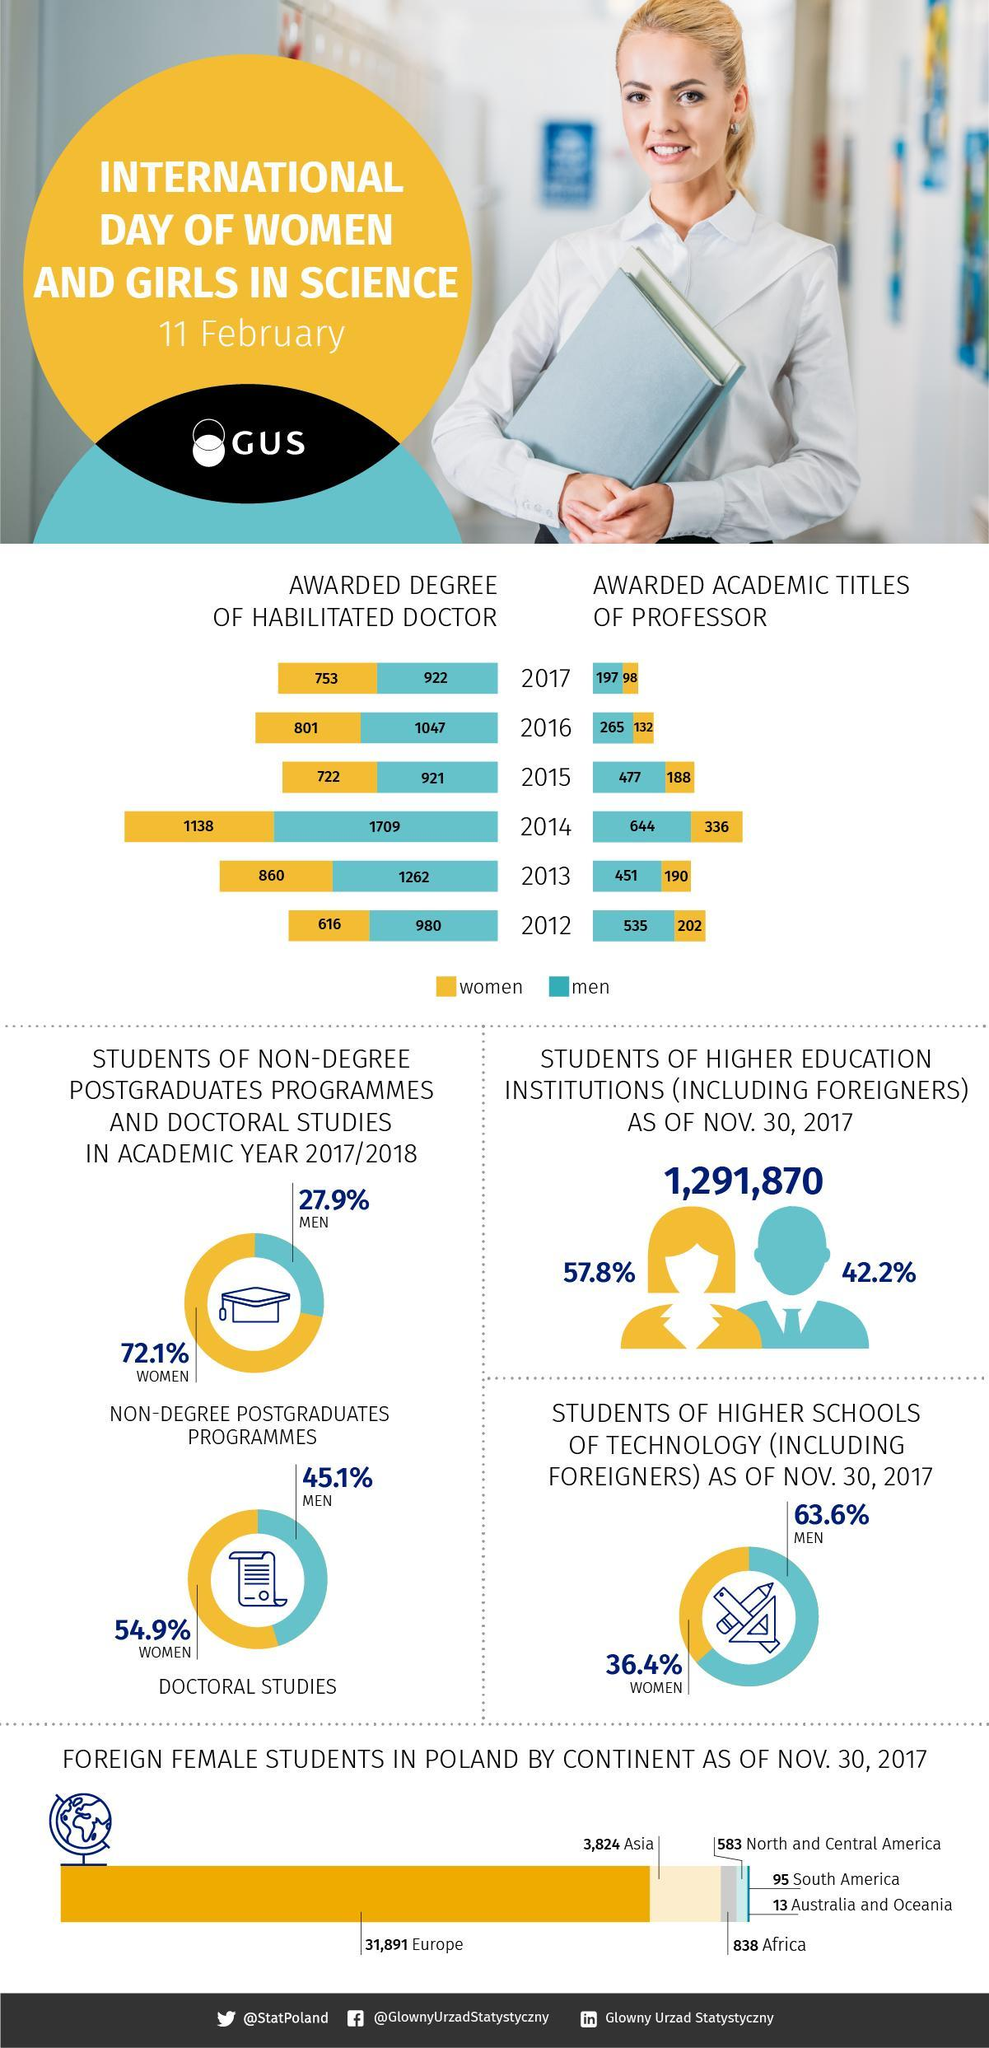What was the number of professor title conferred in 2017 for men, 197, 98, 922,or 801?
Answer the question with a short phrase. 197 What was the number of foreign women students in 2017? 746700.86 Which continent had the third least number of students studying in Poland? North and Central America When was the lowest number of PhD's conferred to women? 2012 What is the number of women conferred PhD's in the year 2014, 1138, 1709, 336, or 644? 1138 When was the highest number of women conferred professor titles? 2014 What was the number of foreign men students in 2017? 607178.9 